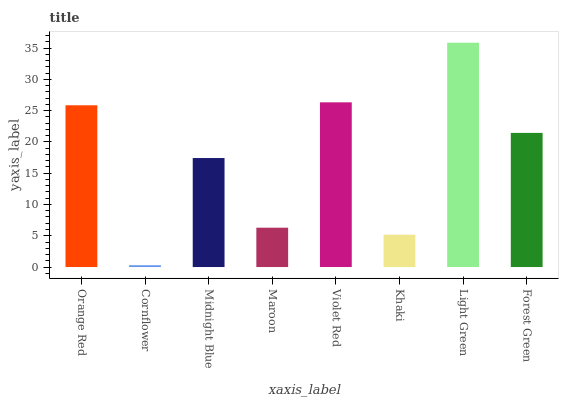Is Cornflower the minimum?
Answer yes or no. Yes. Is Light Green the maximum?
Answer yes or no. Yes. Is Midnight Blue the minimum?
Answer yes or no. No. Is Midnight Blue the maximum?
Answer yes or no. No. Is Midnight Blue greater than Cornflower?
Answer yes or no. Yes. Is Cornflower less than Midnight Blue?
Answer yes or no. Yes. Is Cornflower greater than Midnight Blue?
Answer yes or no. No. Is Midnight Blue less than Cornflower?
Answer yes or no. No. Is Forest Green the high median?
Answer yes or no. Yes. Is Midnight Blue the low median?
Answer yes or no. Yes. Is Violet Red the high median?
Answer yes or no. No. Is Cornflower the low median?
Answer yes or no. No. 